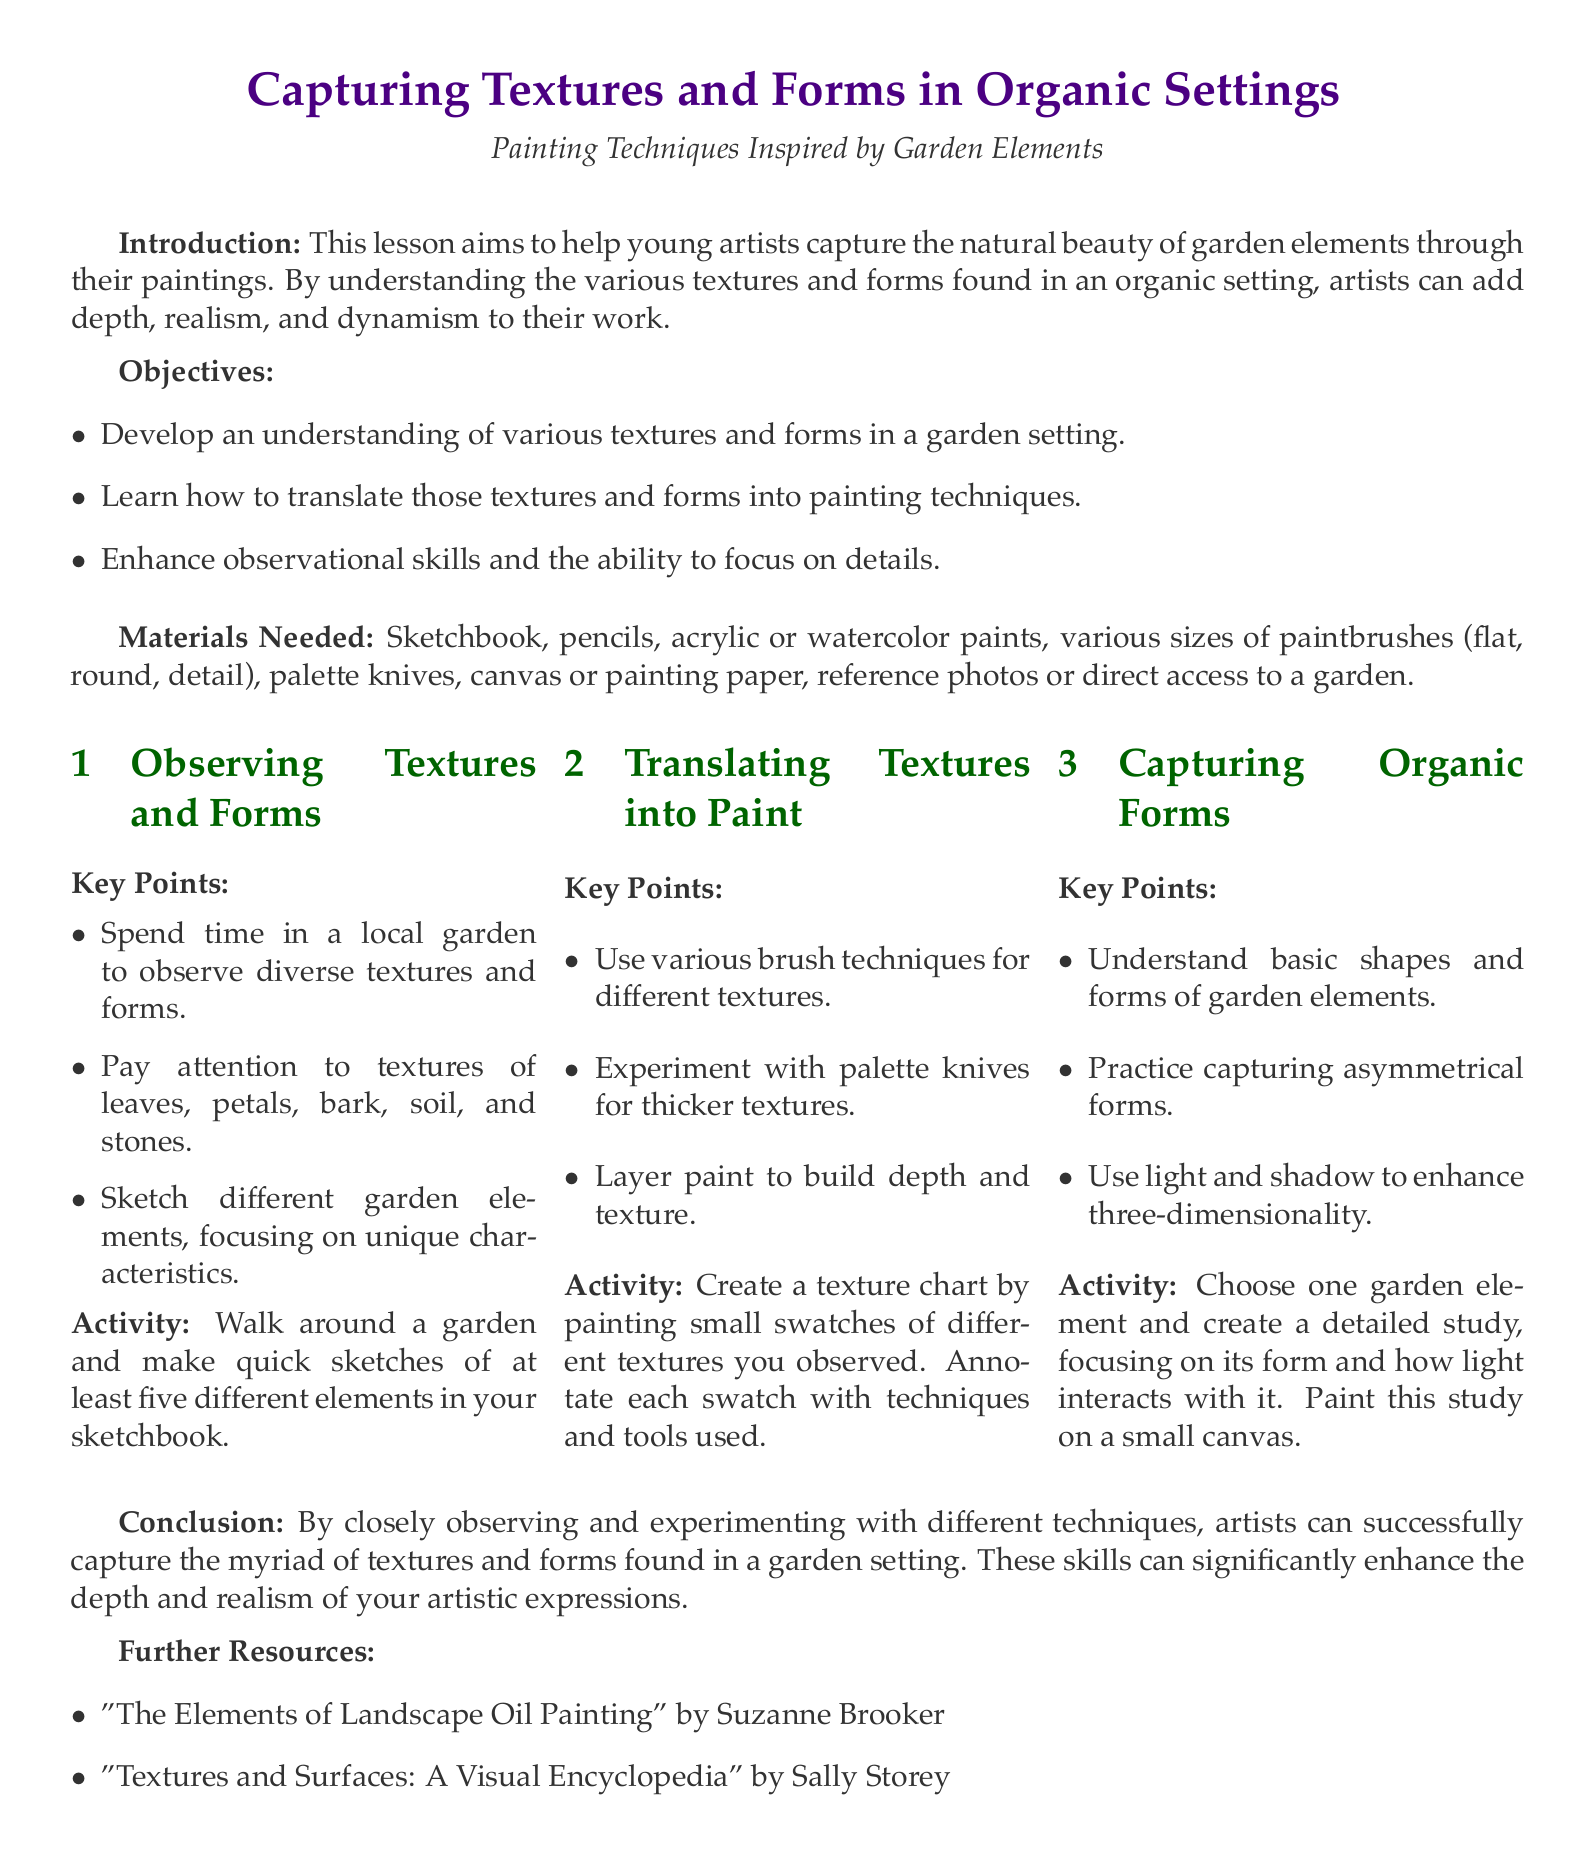what is the title of the lesson plan? The title is stated at the beginning of the document as "Capturing Textures and Forms in Organic Settings."
Answer: Capturing Textures and Forms in Organic Settings what is the main objective of the lesson? The primary aim stated in the objectives section is to help artists capture the natural beauty of garden elements through their paintings.
Answer: Capture natural beauty how many materials are listed in the lesson plan? The number of materials can be counted in the "Materials Needed" section, which lists 8 items.
Answer: 8 what should students create to practice translating textures into paint? The document specifies that students should create a texture chart to practice this skill.
Answer: Texture chart which painting technique is suggested for thicker textures? The document mentions using palette knives as a technique for thicker textures.
Answer: Palette knives what is the first activity students are asked to do in the lesson? The initial activity requires students to walk around a garden and make quick sketches of at least five different elements.
Answer: Quick sketches what type of forms should students practice capturing? The key points suggest students should practice capturing asymmetrical forms in their studies.
Answer: Asymmetrical forms which book is suggested for further reading on landscape oil painting? The lesson plan lists "The Elements of Landscape Oil Painting" by Suzanne Brooker as a resource.
Answer: The Elements of Landscape Oil Painting 